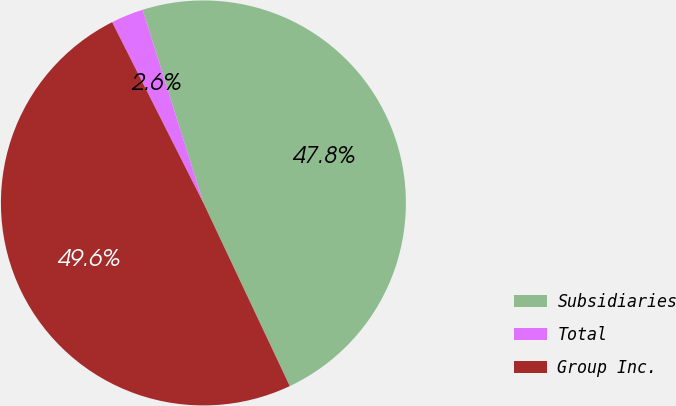<chart> <loc_0><loc_0><loc_500><loc_500><pie_chart><fcel>Subsidiaries<fcel>Total<fcel>Group Inc.<nl><fcel>47.84%<fcel>2.59%<fcel>49.57%<nl></chart> 